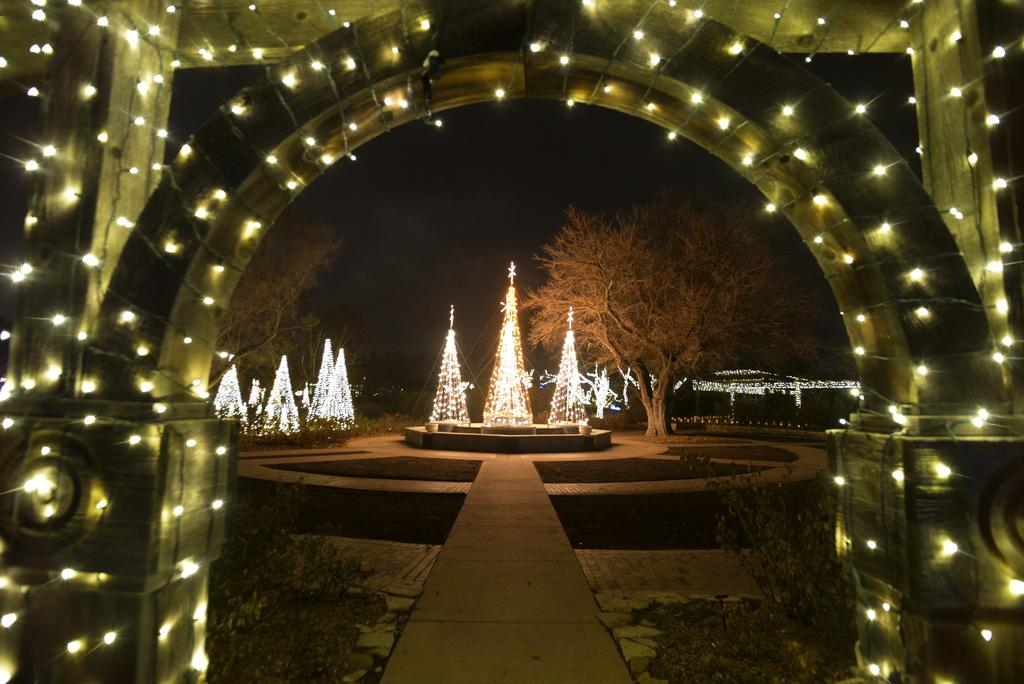What structure is present in the image? There is an arch in the image. What decorations are on the arch? There are fairy lights on the arch. What can be seen in the center of the image? There is a path in the center of the image. What is illuminated in the trees? There are lights on the trees. How would you describe the lighting conditions in the background of the image? The background of the image is dark. What story is being told by the grass in the image? There is no grass present in the image, so no story can be told by it. 